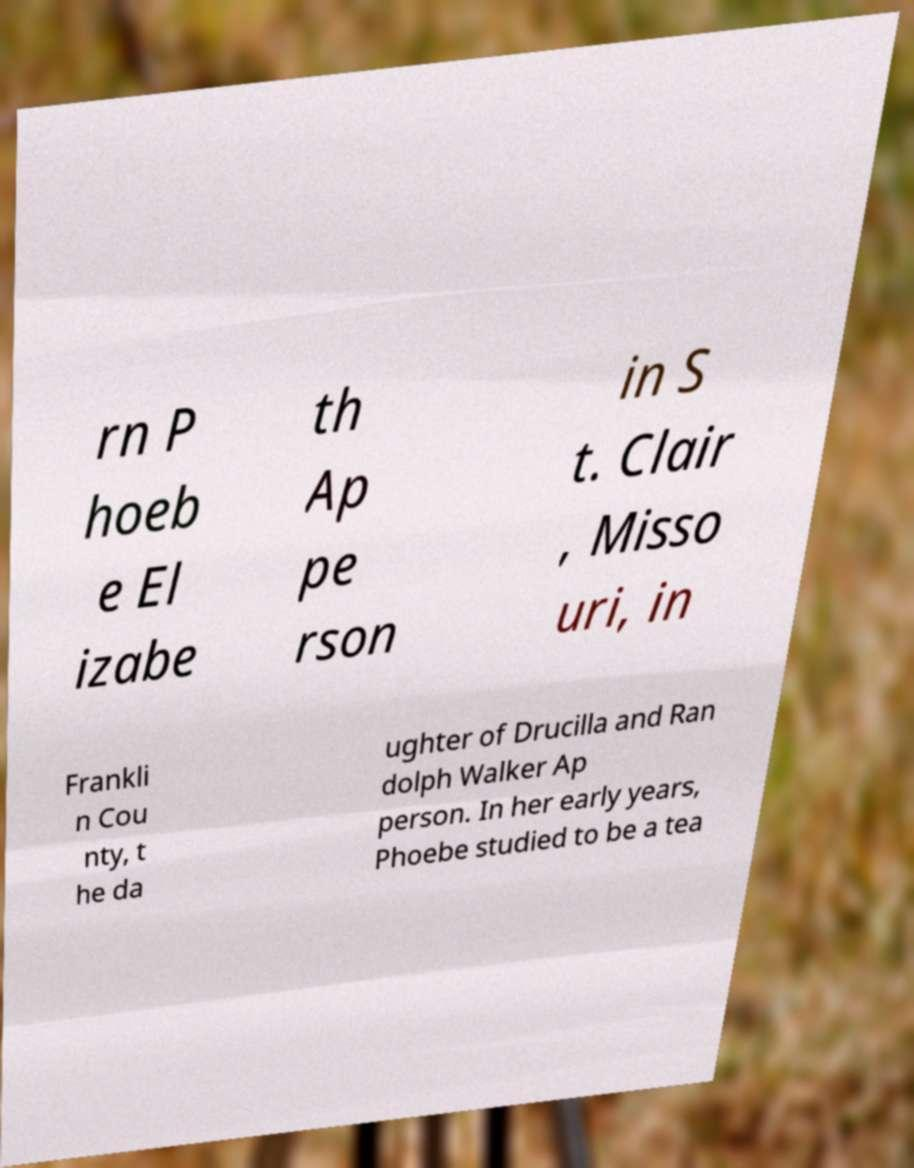Please identify and transcribe the text found in this image. rn P hoeb e El izabe th Ap pe rson in S t. Clair , Misso uri, in Frankli n Cou nty, t he da ughter of Drucilla and Ran dolph Walker Ap person. In her early years, Phoebe studied to be a tea 